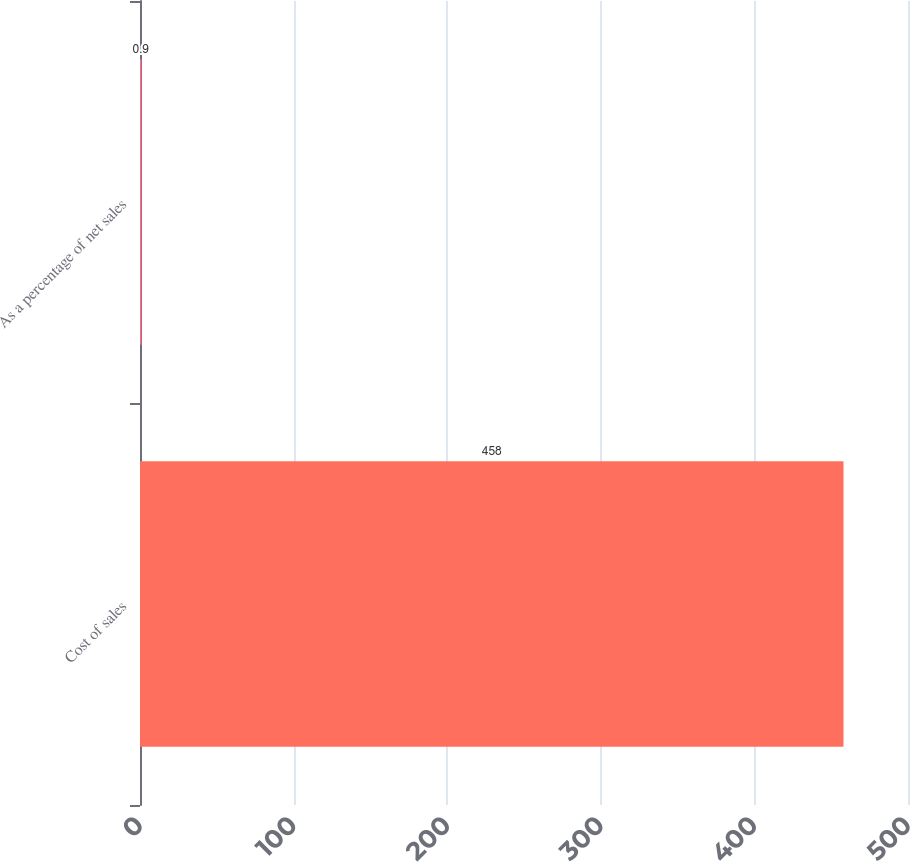Convert chart. <chart><loc_0><loc_0><loc_500><loc_500><bar_chart><fcel>Cost of sales<fcel>As a percentage of net sales<nl><fcel>458<fcel>0.9<nl></chart> 